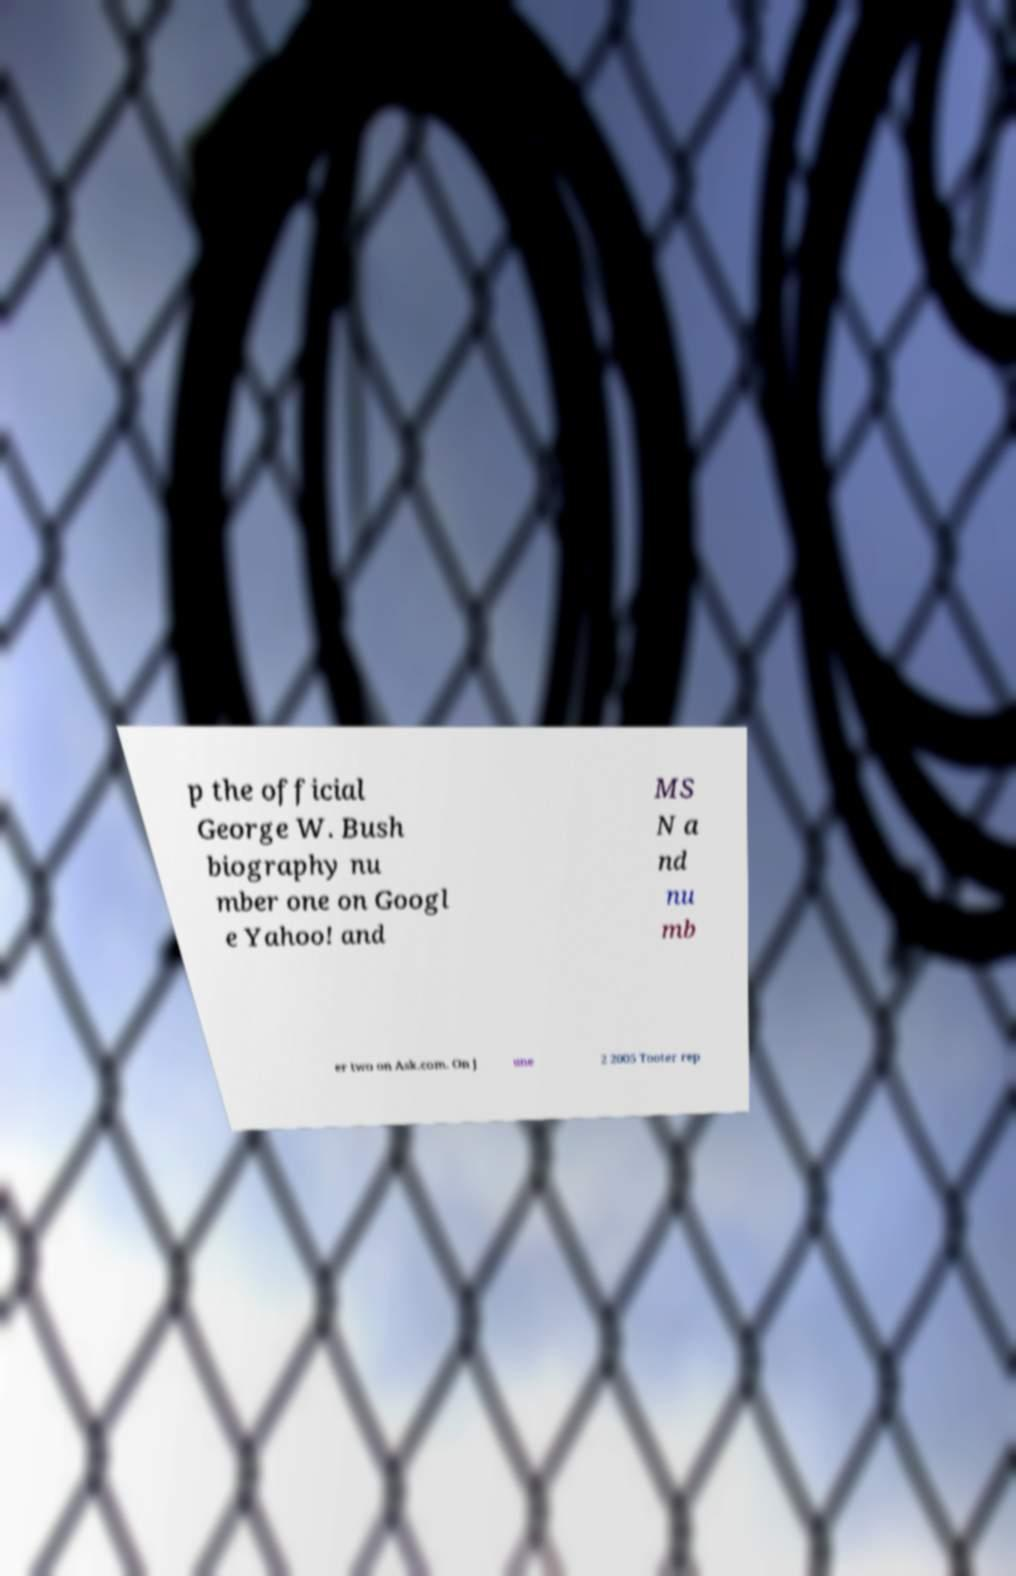Please identify and transcribe the text found in this image. p the official George W. Bush biography nu mber one on Googl e Yahoo! and MS N a nd nu mb er two on Ask.com. On J une 2 2005 Tooter rep 